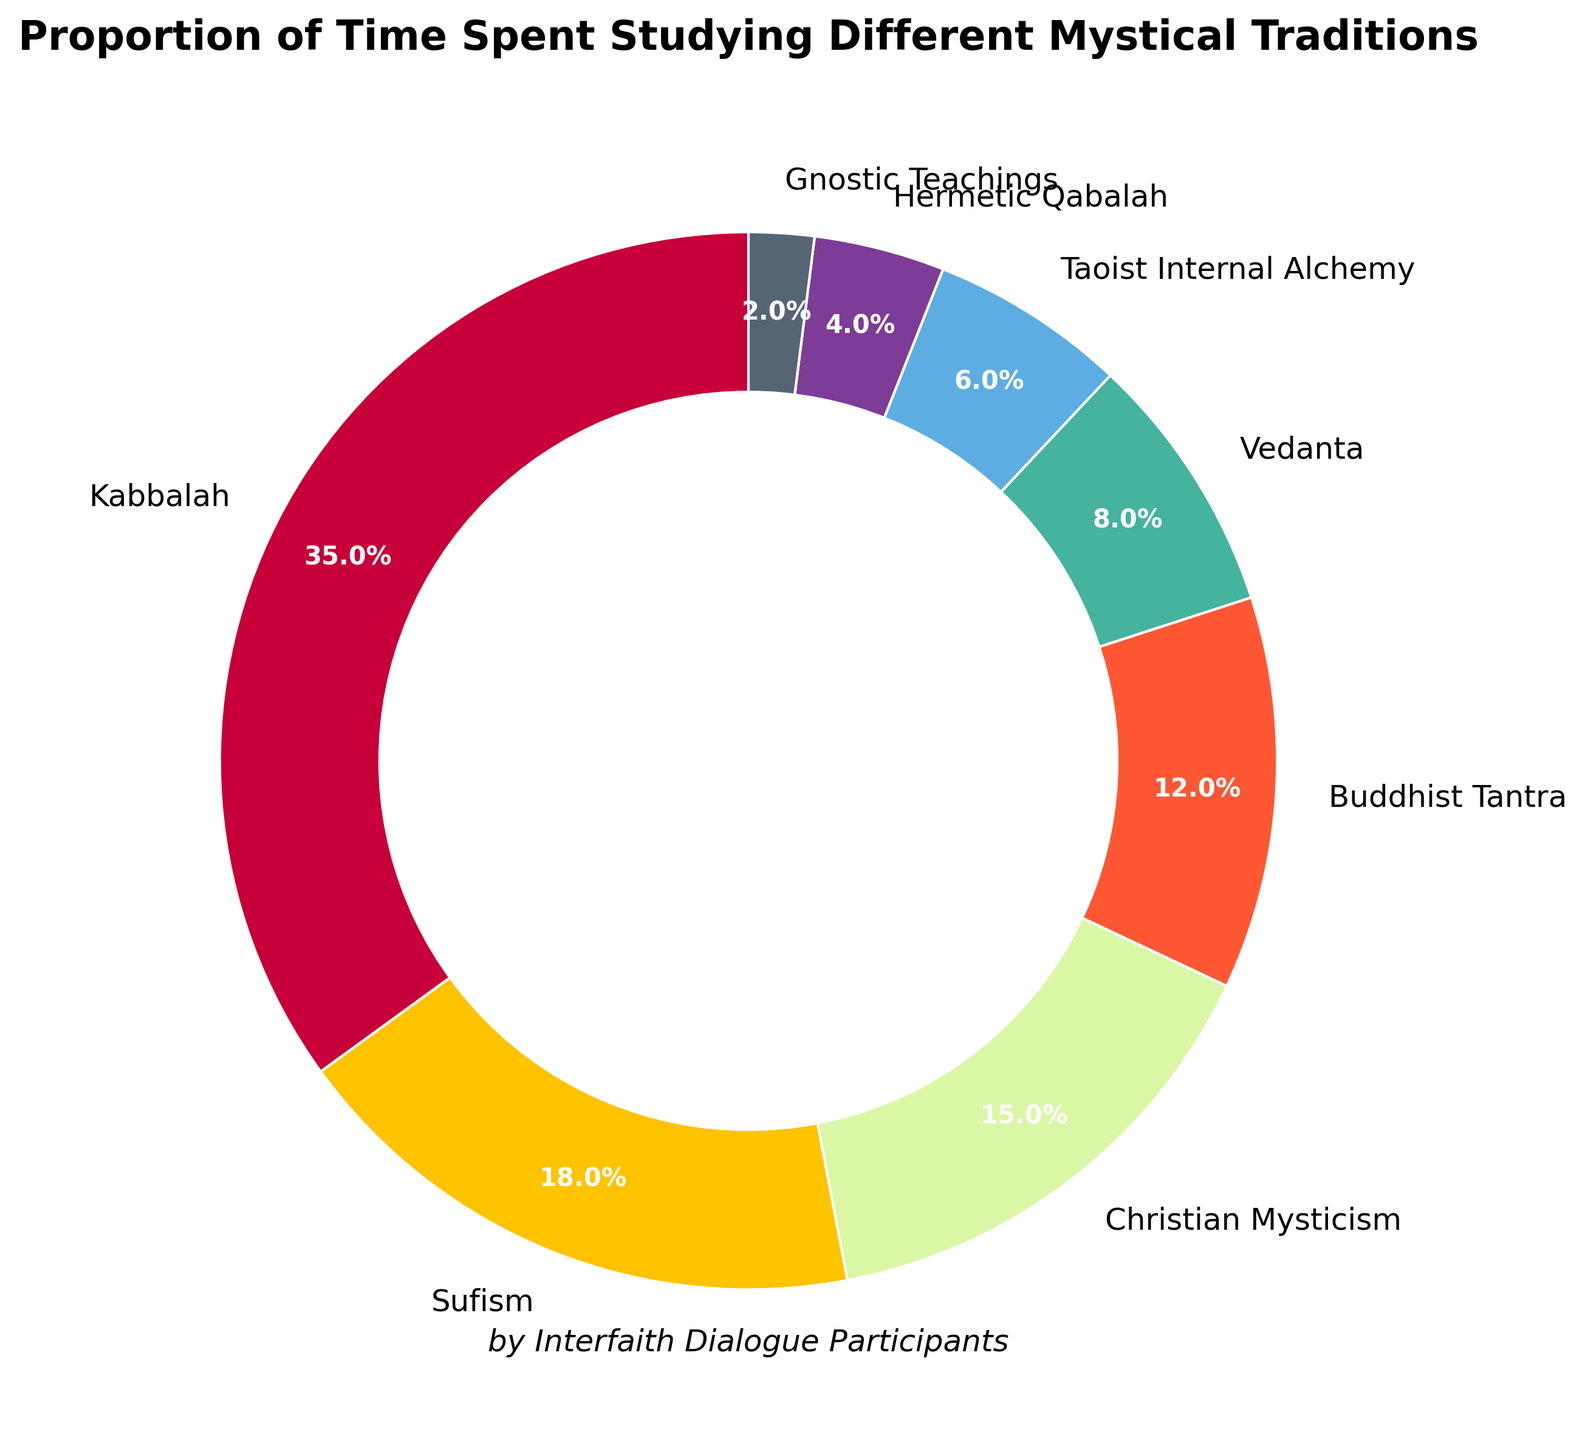What percentage of time is spent on Kabbalah compared to Buddhist Tantra? Kabbalah is 35% and Buddhist Tantra is 12%. Subtracting the smaller percentage from the larger one: 35% - 12% = 23%
Answer: 23% Which tradition has a smaller proportion of time spent than Sufism but larger than Vedanta? Sufism has 18%, and Vedanta has 8%. Checking between them are Christian Mysticism (15%) and Buddhist Tantra (12%). Both fit the criteria.
Answer: Christian Mysticism, Buddhist Tantra What is the combined percentage of time spent studying Hermetic Qabalah and Gnostic Teachings? Hermetic Qabalah is 4%, and Gnostic Teachings is 2%. Adding them together: 4% + 2% = 6%
Answer: 6% Is the time spent on Christian Mysticism greater or less than the time spent on Taoist Internal Alchemy? Christian Mysticism is 15%, and Taoist Internal Alchemy is 6%. The percentage for Christian Mysticism is greater.
Answer: Greater What is the total percentage of time spent on the three lowest traditions? The three lowest are Hermetic Qabalah (4%), Taoist Internal Alchemy (6%), and Gnostic Teachings (2%). Adding them: 4% + 6% + 2% = 12%
Answer: 12% What tradition corresponds to the slice with the color closest to green? The color closest to green in the pie chart is associated with Buddhist Tantra.
Answer: Buddhist Tantra Which group has the second highest proportion of time spent? The highest is Kabbalah at 35%, and the second highest is Sufism at 18%.
Answer: Sufism Of Kabbalah, Vedanta, and Hermetic Qabalah, which tradition has the median time spent? The percentages for Kabbalah (35%), Vedanta (8%), and Hermetic Qabalah (4%) are given. Arranging them in order: 4%, 8%, 35%. The median percentage is 8%.
Answer: Vedanta How much more time is spent on Kabbalah than on the total time spent on Vedanta and Taoist Internal Alchemy? Kabbalah is 35%. Vedanta is 8%, and Taoist Internal Alchemy is 6%. Adding the latter two: 8% + 6% = 14%. Subtracting: 35% - 14% = 21%
Answer: 21% Which tradition takes up a larger proportion than Vedanta but a smaller proportion than Christian Mysticism? Vedanta is 8% and Christian Mysticism is 15%. Sufism (18%) is out, leaving Buddhist Tantra (12%) as the correct choice.
Answer: Buddhist Tantra 